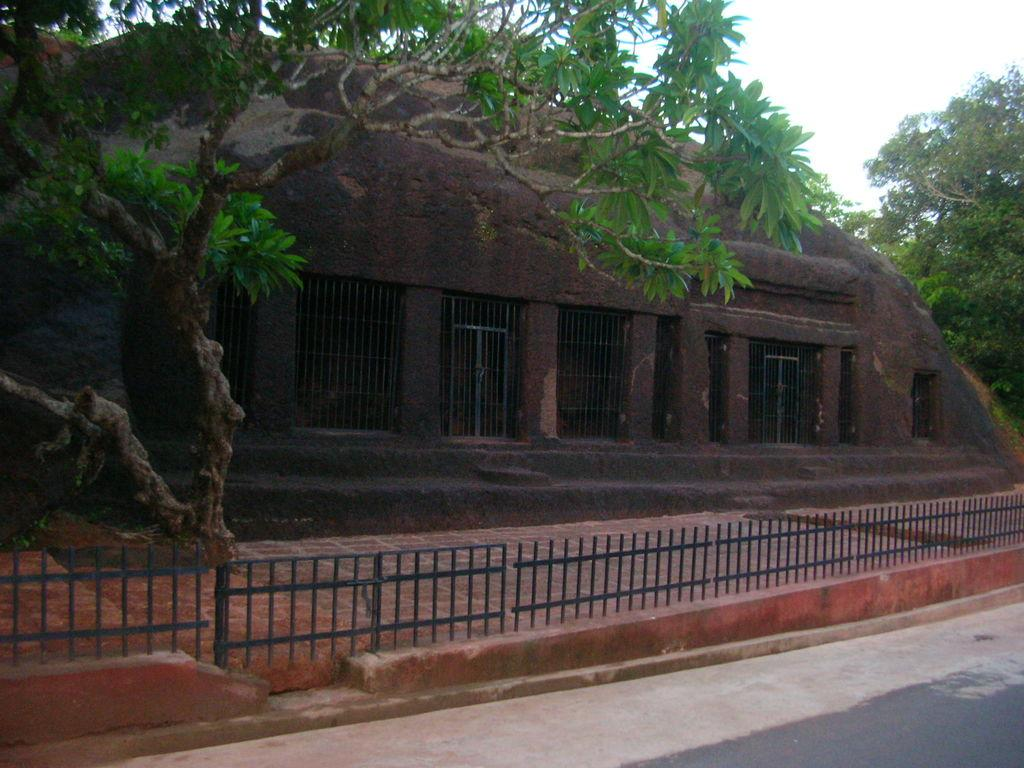What is located at the front of the image? There is a fence in the front of the image. What can be seen in the background of the image? There is a building and trees in the background of the image. What feature is present on the building? There are gates on the building. What type of plate is hanging on the fence in the image? There is no plate present on the fence in the image. How many locks are visible on the gates of the building? The provided facts do not mention any locks on the gates of the building, so we cannot determine the number of locks. 